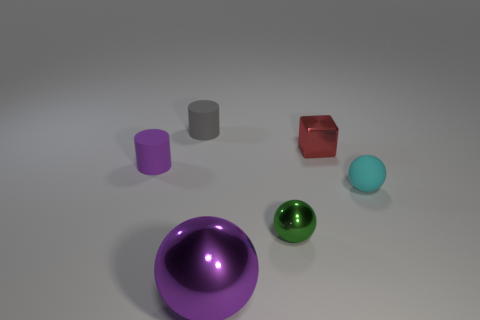What material is the small cylinder that is the same color as the large metallic thing? The small cylinder appears to have a matte surface similar to the larger metallic object, suggesting it could be made of a material like painted metal or plastic, rather than rubber. 